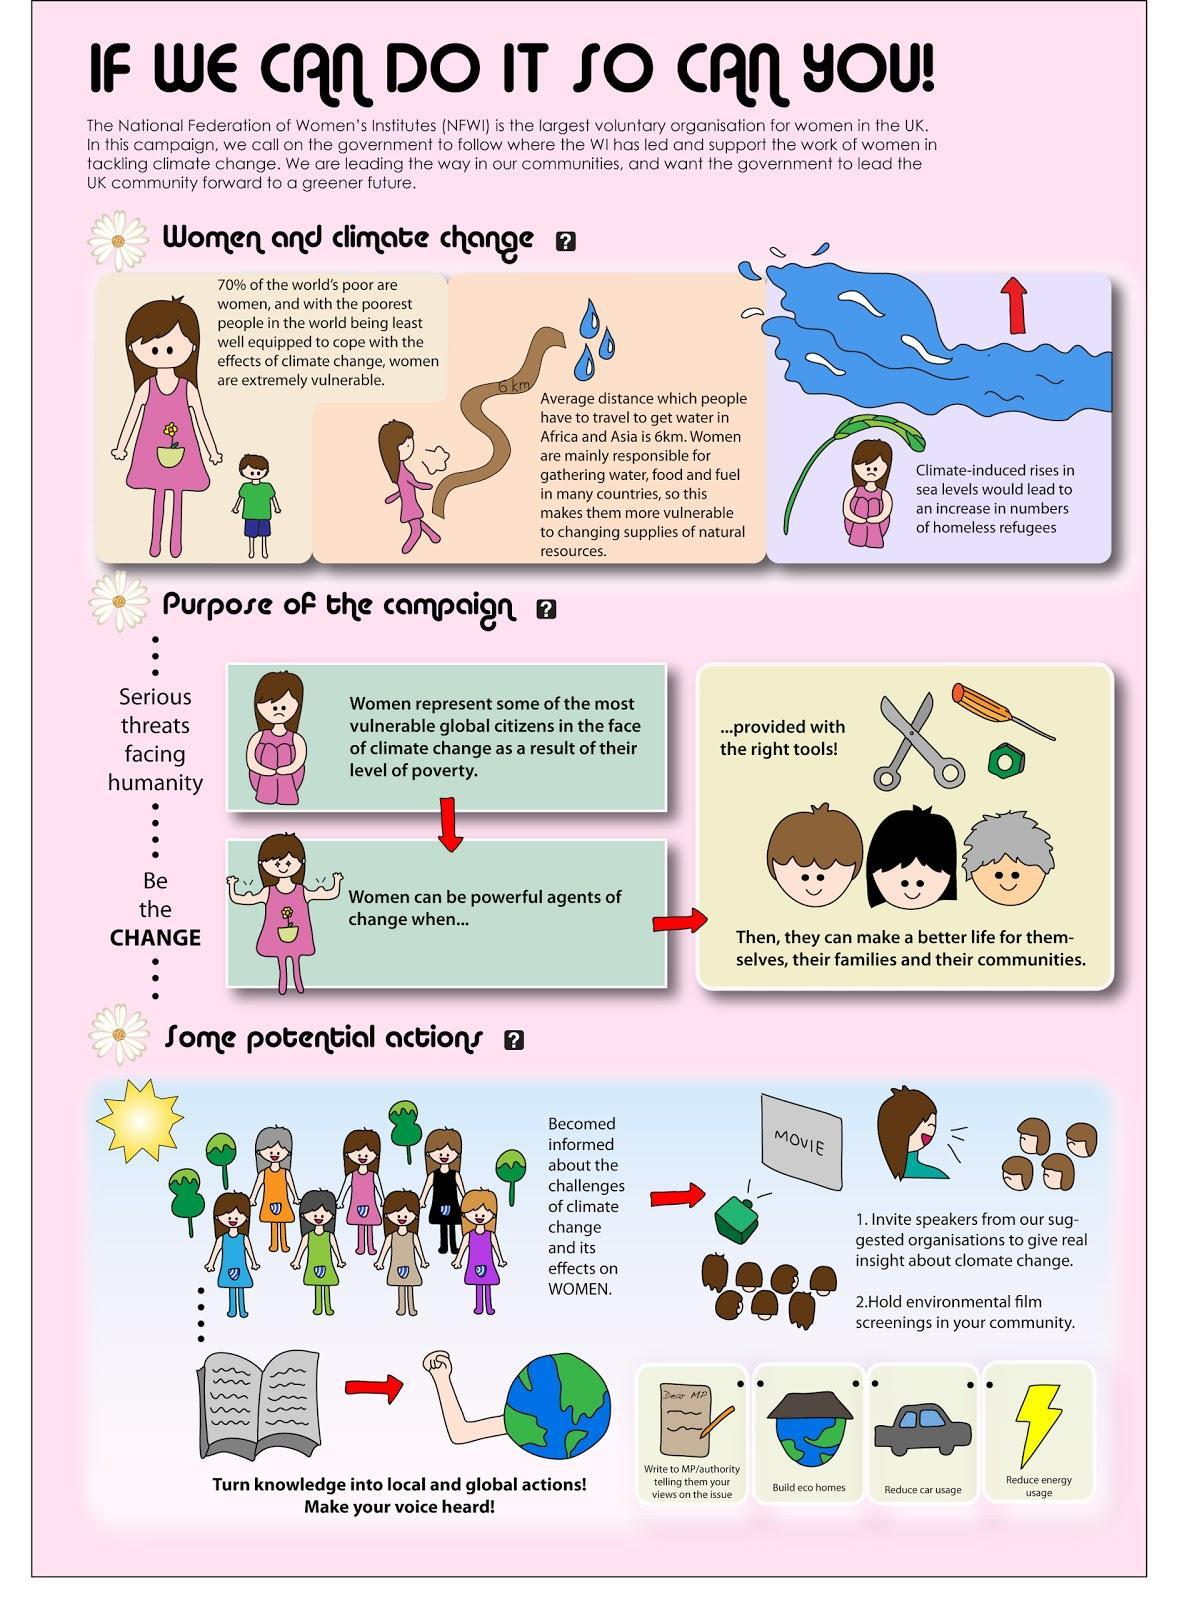What percentage of the world's poor are not women?
Answer the question with a short phrase. 30% 